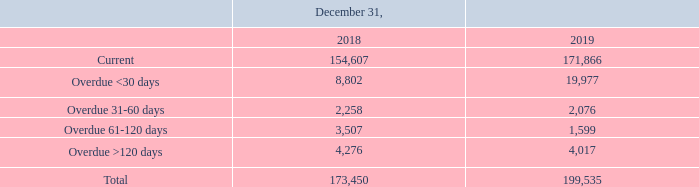NOTE 9. ACCOUNTS RECEIVABLE
A significant percentage of our accounts receivable is derived from sales to a limited number of large multinational semiconductor device manufacturers located throughout the world. In order to monitor potential expected credit losses, we perform ongoing credit evaluations of our customers’ financial condition.
The carrying amount of accounts receivable is as follows:
How does the company monitor potential expected credit losses? Perform ongoing credit evaluations of our customers’ financial condition. What are the time frames of carrying amount of accounts receivable? Current, overdue <30 days, overdue 31-60 days, overdue 61-120 days, overdue >120 days. What is the Current 2019 carrying amount of accounts receivable? 171,866. What is the time period with the greatest carrying amount of accounts receivable for 2019? For COL4 rows 3 to 7 find the largest number and the corresponding time period in COL2
Answer: current. What is the percentage change in total carrying amount of accounts receivable from 2018 to 2019?
Answer scale should be: percent. ( 199,535 - 173,450 )/ 173,450 
Answer: 15.04. What is the change in current carrying amount of accounts receivable for 2018 to 2019?  171,866 - 154,607 
Answer: 17259. 